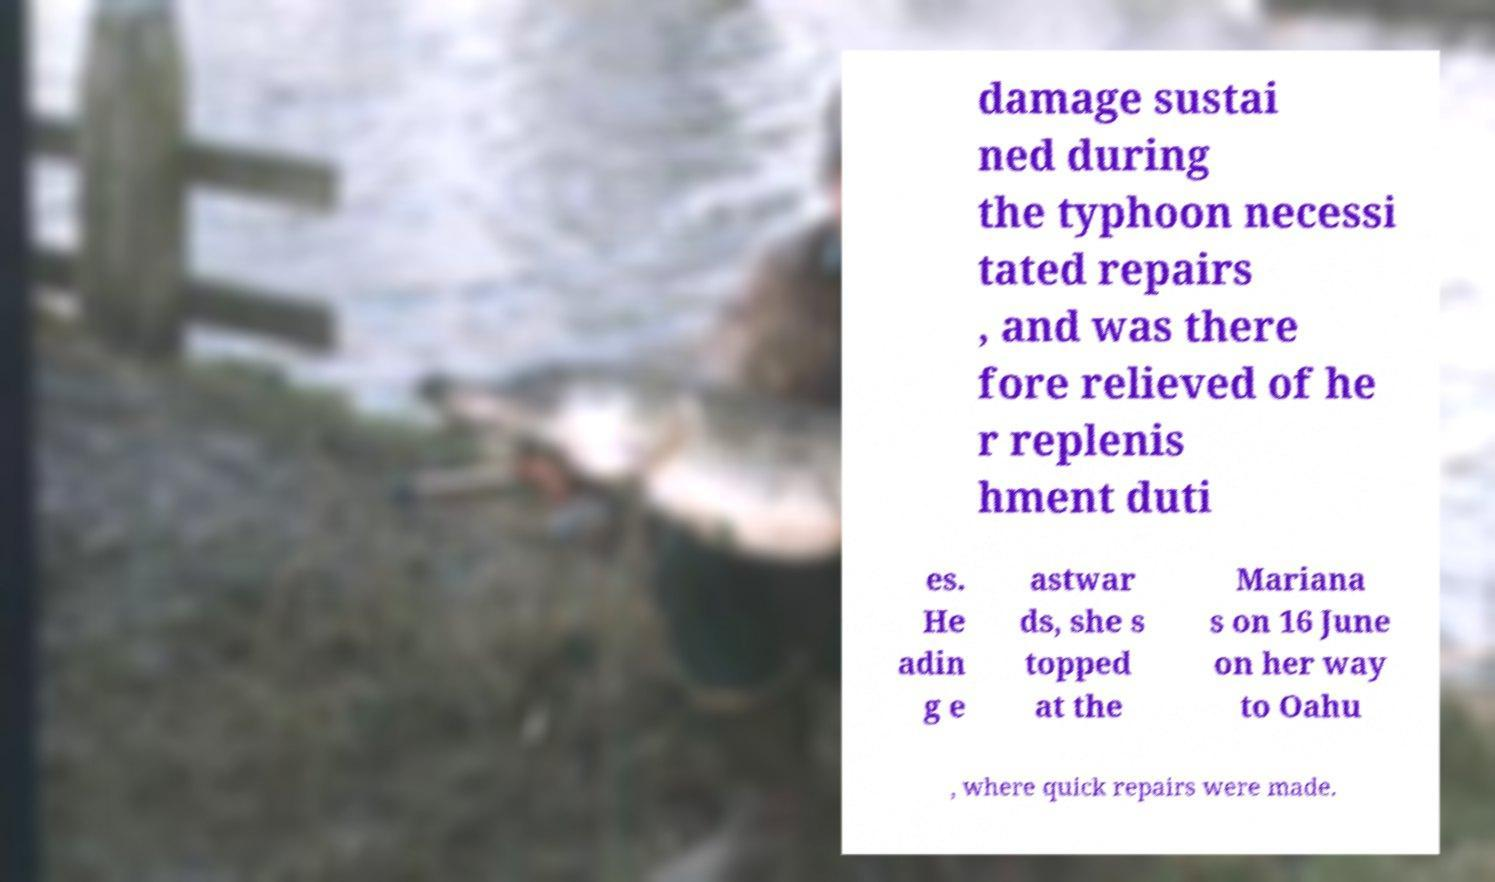Could you assist in decoding the text presented in this image and type it out clearly? damage sustai ned during the typhoon necessi tated repairs , and was there fore relieved of he r replenis hment duti es. He adin g e astwar ds, she s topped at the Mariana s on 16 June on her way to Oahu , where quick repairs were made. 